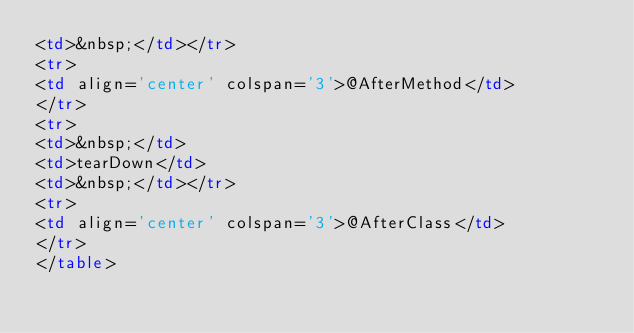<code> <loc_0><loc_0><loc_500><loc_500><_HTML_><td>&nbsp;</td></tr>
<tr>
<td align='center' colspan='3'>@AfterMethod</td>
</tr>
<tr>
<td>&nbsp;</td>
<td>tearDown</td>
<td>&nbsp;</td></tr>
<tr>
<td align='center' colspan='3'>@AfterClass</td>
</tr>
</table>
</code> 